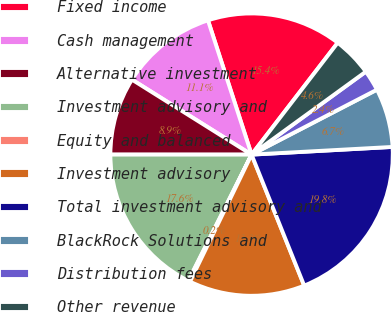Convert chart to OTSL. <chart><loc_0><loc_0><loc_500><loc_500><pie_chart><fcel>Fixed income<fcel>Cash management<fcel>Alternative investment<fcel>Investment advisory and<fcel>Equity and balanced<fcel>Investment advisory<fcel>Total investment advisory and<fcel>BlackRock Solutions and<fcel>Distribution fees<fcel>Other revenue<nl><fcel>15.44%<fcel>11.09%<fcel>8.91%<fcel>17.61%<fcel>0.21%<fcel>13.26%<fcel>19.79%<fcel>6.74%<fcel>2.39%<fcel>4.56%<nl></chart> 